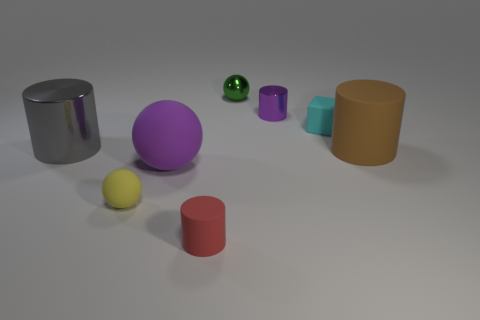Does the big rubber ball have the same color as the tiny metallic cylinder?
Offer a terse response. Yes. Do the metal cylinder that is on the right side of the yellow thing and the large sphere have the same color?
Ensure brevity in your answer.  Yes. There is a metal thing that is the same color as the large ball; what shape is it?
Make the answer very short. Cylinder. What number of cubes are tiny things or large gray metal things?
Your response must be concise. 1. What color is the other metallic thing that is the same size as the green thing?
Your response must be concise. Purple. The rubber thing that is left of the big matte object to the left of the green ball is what shape?
Provide a succinct answer. Sphere. Is the size of the metal thing that is left of the red thing the same as the red matte thing?
Ensure brevity in your answer.  No. How many other things are there of the same material as the tiny cyan object?
Make the answer very short. 4. What number of brown objects are tiny metallic balls or small matte objects?
Offer a very short reply. 0. There is a metal object that is the same color as the large sphere; what is its size?
Your answer should be compact. Small. 